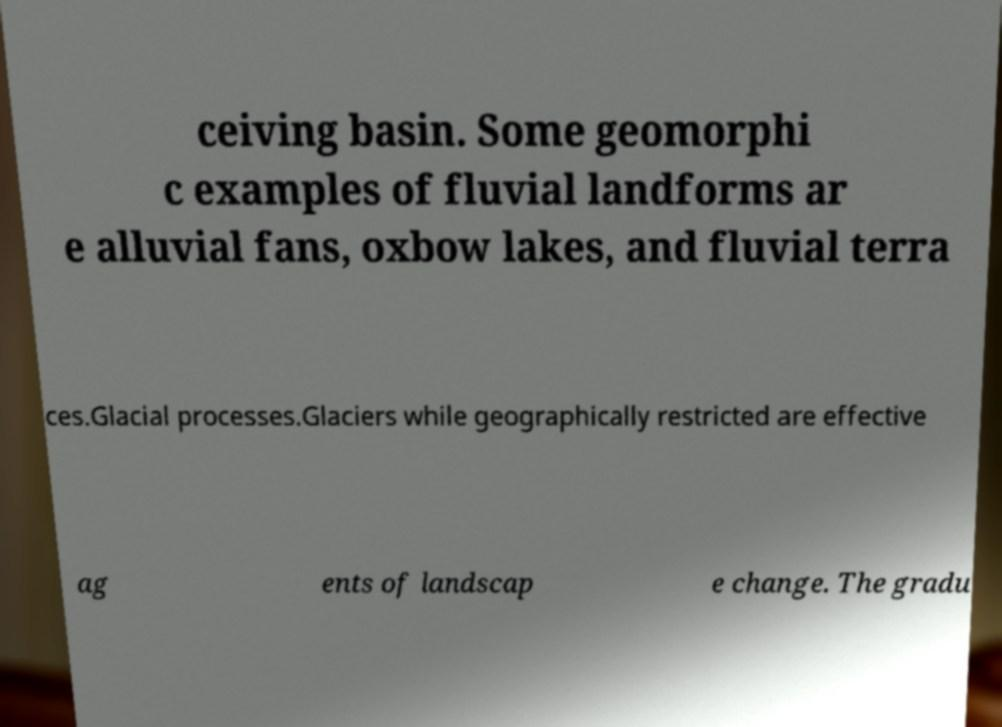Could you assist in decoding the text presented in this image and type it out clearly? ceiving basin. Some geomorphi c examples of fluvial landforms ar e alluvial fans, oxbow lakes, and fluvial terra ces.Glacial processes.Glaciers while geographically restricted are effective ag ents of landscap e change. The gradu 